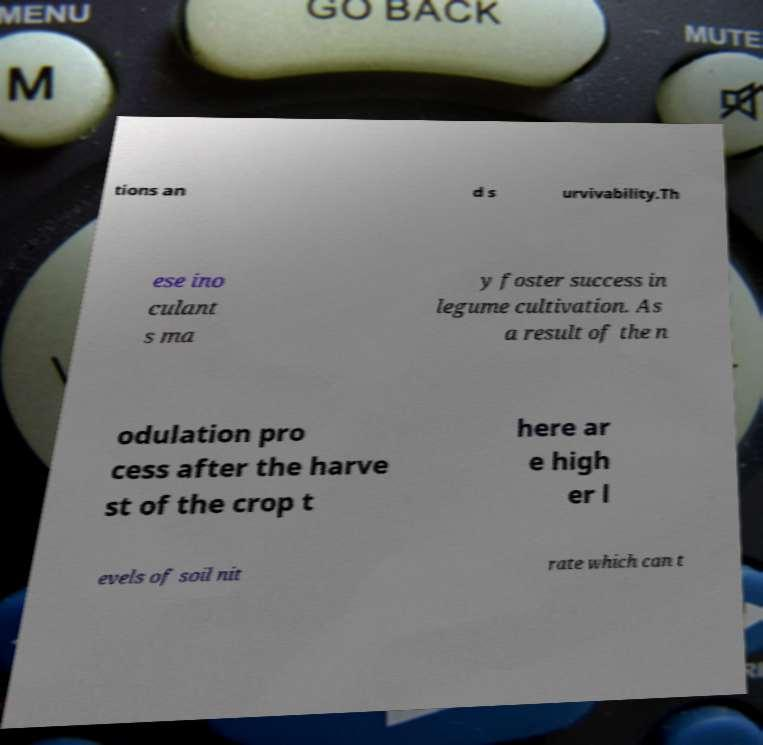What messages or text are displayed in this image? I need them in a readable, typed format. tions an d s urvivability.Th ese ino culant s ma y foster success in legume cultivation. As a result of the n odulation pro cess after the harve st of the crop t here ar e high er l evels of soil nit rate which can t 